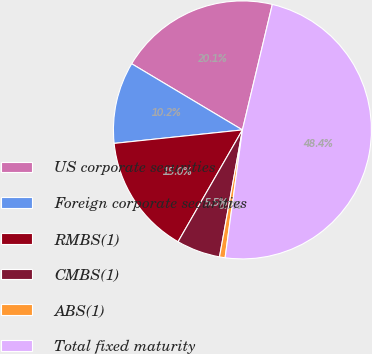Convert chart to OTSL. <chart><loc_0><loc_0><loc_500><loc_500><pie_chart><fcel>US corporate securities<fcel>Foreign corporate securities<fcel>RMBS(1)<fcel>CMBS(1)<fcel>ABS(1)<fcel>Total fixed maturity<nl><fcel>20.15%<fcel>10.24%<fcel>15.02%<fcel>5.47%<fcel>0.7%<fcel>48.42%<nl></chart> 